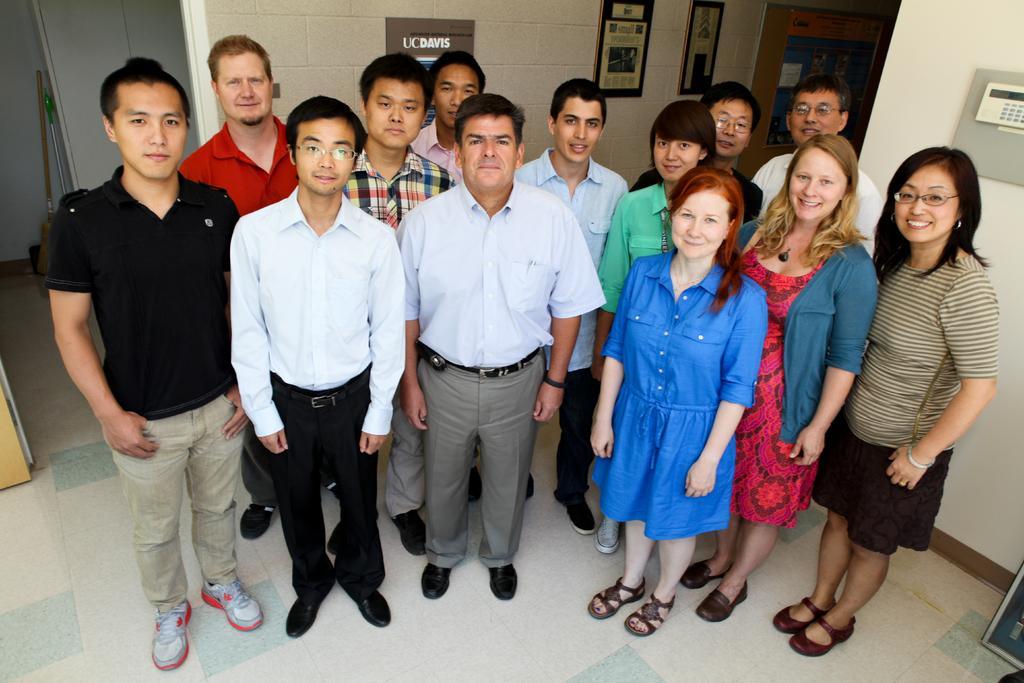How would you summarize this image in a sentence or two? In the image we can see there are many people standing, they are wearing clothes and shoes. This is a floor, wall, door, frame, stick and a device. These are the spectacles and bracelet. 